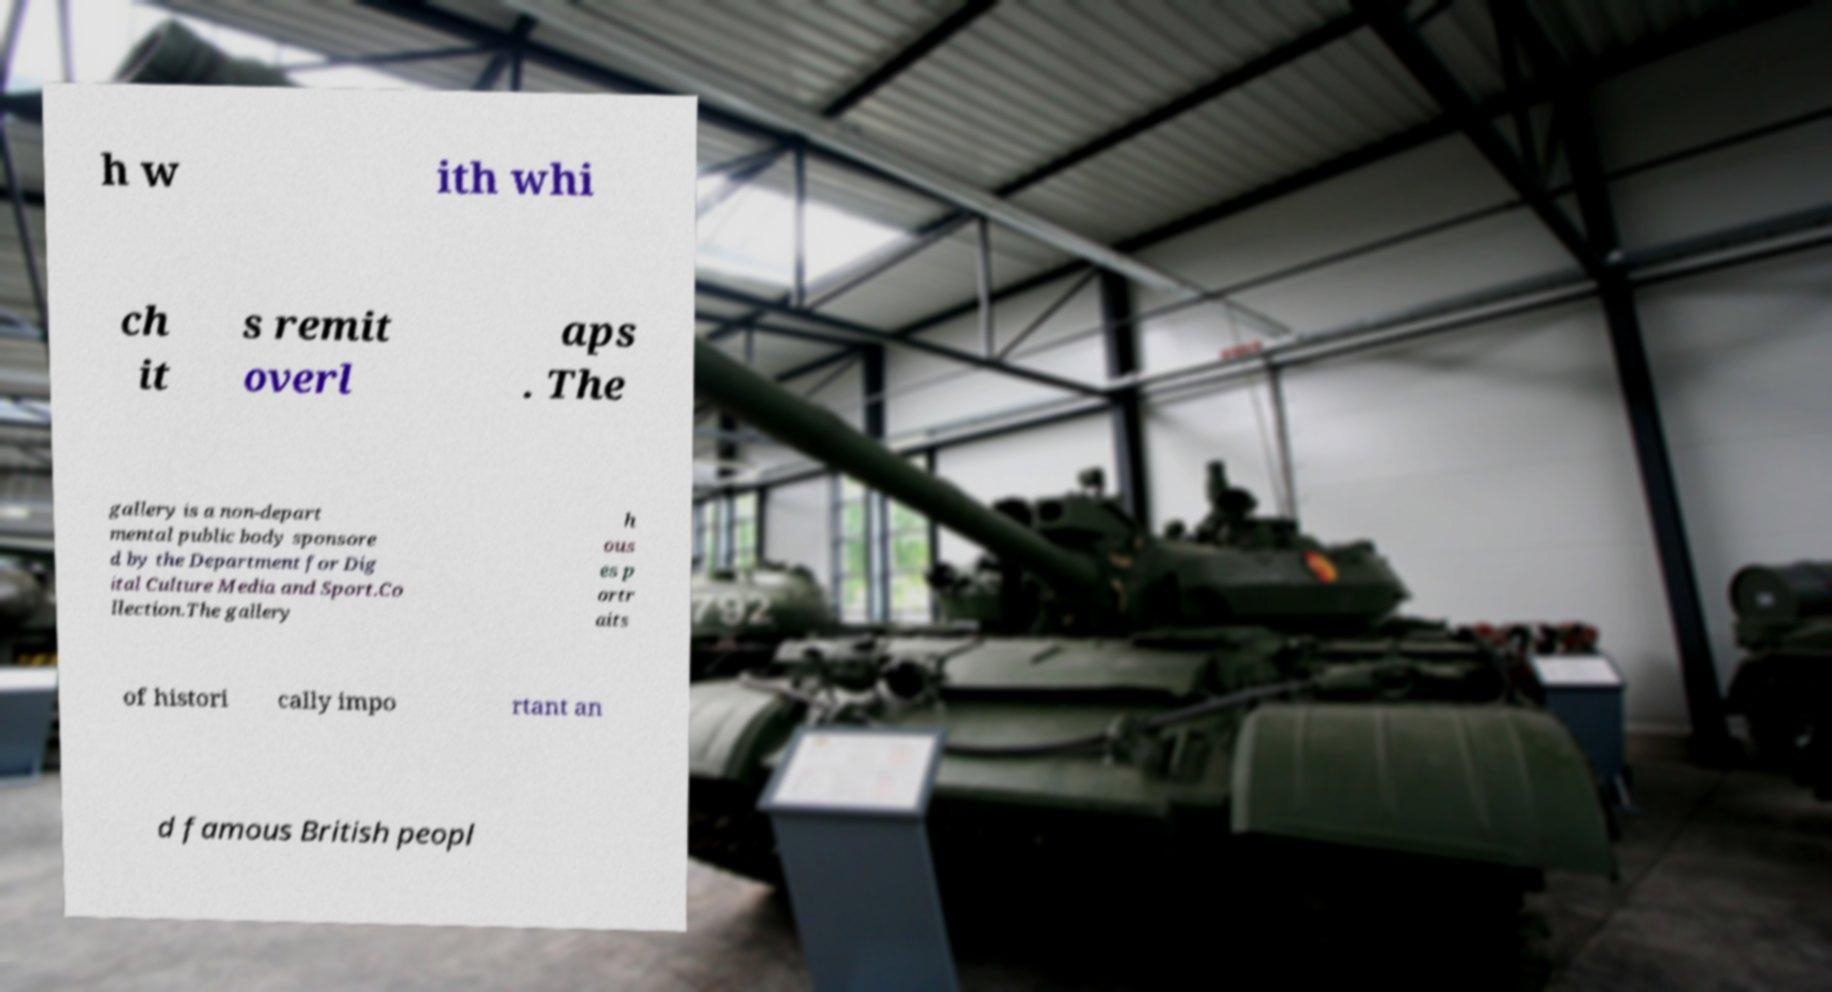Could you assist in decoding the text presented in this image and type it out clearly? h w ith whi ch it s remit overl aps . The gallery is a non-depart mental public body sponsore d by the Department for Dig ital Culture Media and Sport.Co llection.The gallery h ous es p ortr aits of histori cally impo rtant an d famous British peopl 